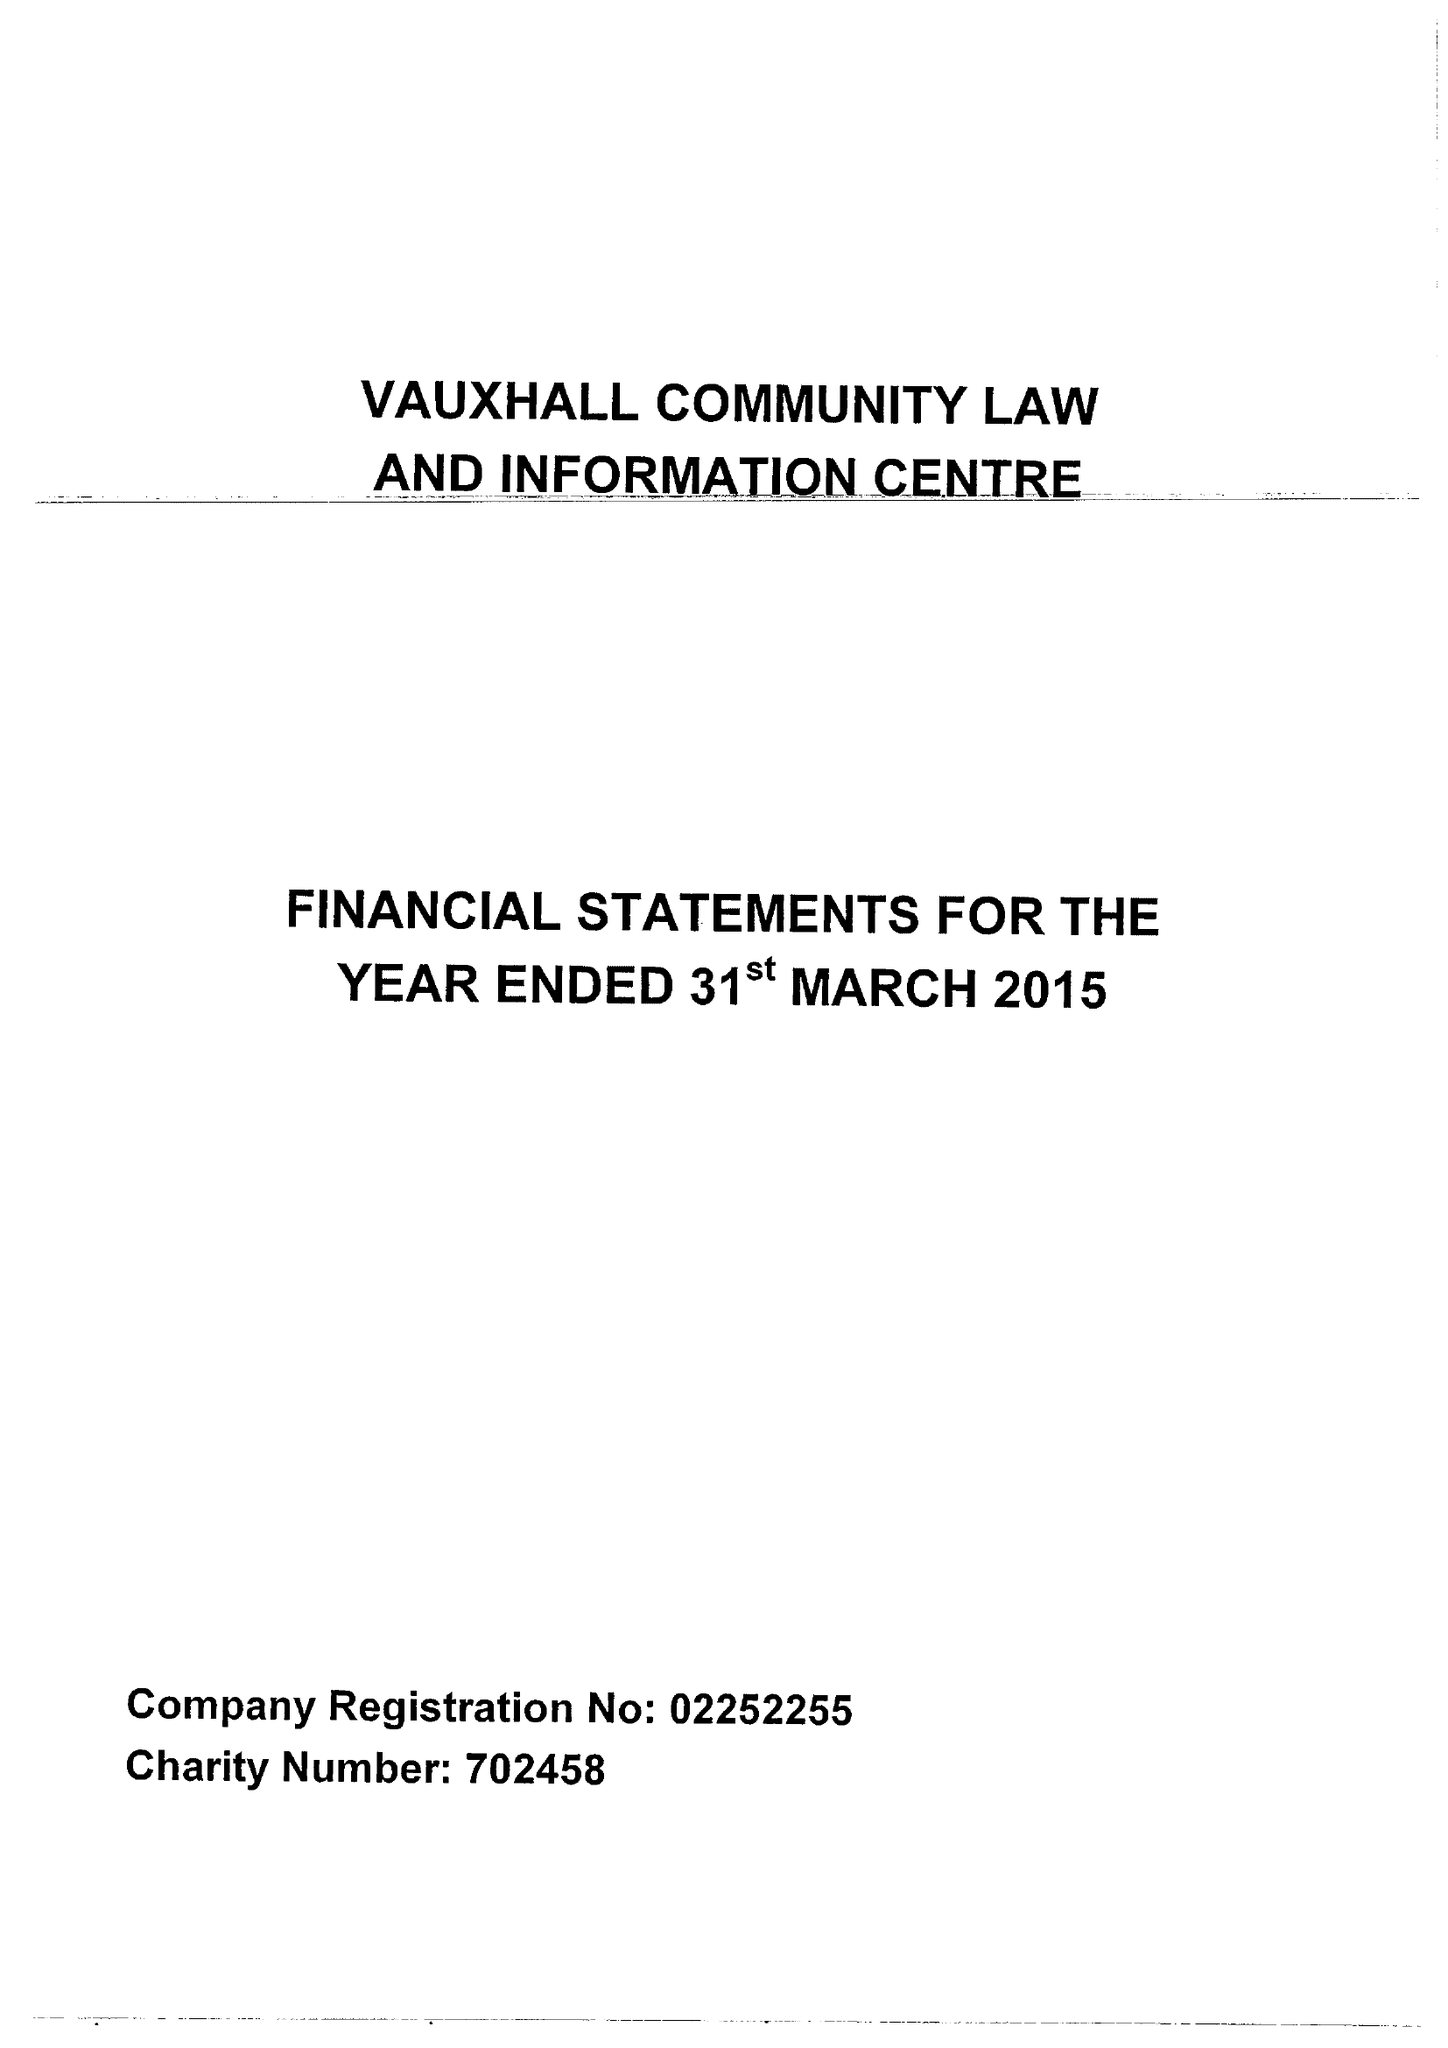What is the value for the spending_annually_in_british_pounds?
Answer the question using a single word or phrase. 65221.00 